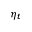Convert formula to latex. <formula><loc_0><loc_0><loc_500><loc_500>\eta _ { t }</formula> 